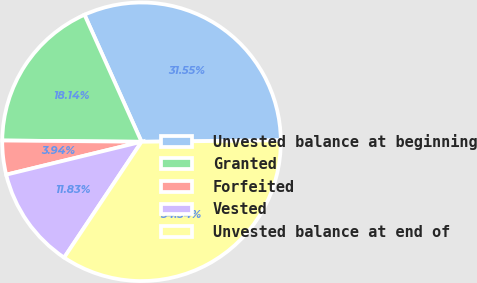<chart> <loc_0><loc_0><loc_500><loc_500><pie_chart><fcel>Unvested balance at beginning<fcel>Granted<fcel>Forfeited<fcel>Vested<fcel>Unvested balance at end of<nl><fcel>31.55%<fcel>18.14%<fcel>3.94%<fcel>11.83%<fcel>34.54%<nl></chart> 